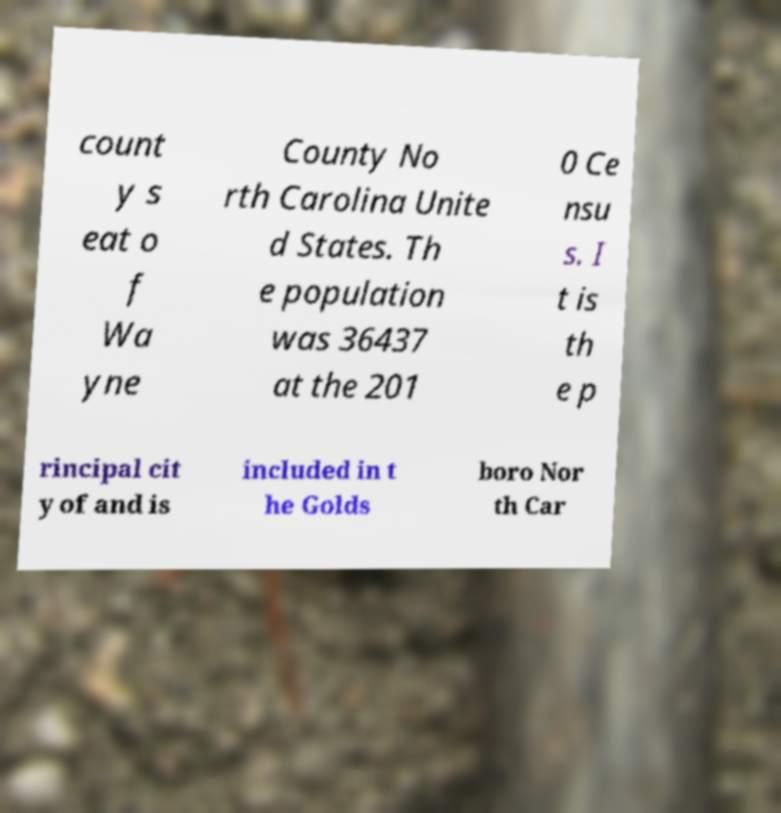Could you extract and type out the text from this image? count y s eat o f Wa yne County No rth Carolina Unite d States. Th e population was 36437 at the 201 0 Ce nsu s. I t is th e p rincipal cit y of and is included in t he Golds boro Nor th Car 